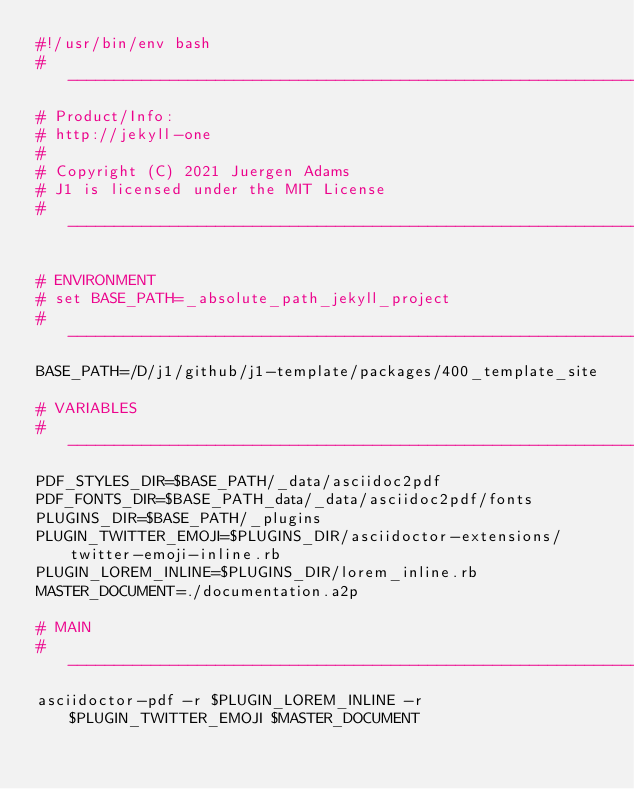<code> <loc_0><loc_0><loc_500><loc_500><_Bash_>#!/usr/bin/env bash
#  -----------------------------------------------------------------------------
# Product/Info:
# http://jekyll-one
#
# Copyright (C) 2021 Juergen Adams
# J1 is licensed under the MIT License
#  -----------------------------------------------------------------------------

# ENVIRONMENT
# set BASE_PATH=_absolute_path_jekyll_project
# ------------------------------------------------------------------------------
BASE_PATH=/D/j1/github/j1-template/packages/400_template_site

# VARIABLES
# ------------------------------------------------------------------------------
PDF_STYLES_DIR=$BASE_PATH/_data/asciidoc2pdf
PDF_FONTS_DIR=$BASE_PATH_data/_data/asciidoc2pdf/fonts
PLUGINS_DIR=$BASE_PATH/_plugins
PLUGIN_TWITTER_EMOJI=$PLUGINS_DIR/asciidoctor-extensions/twitter-emoji-inline.rb
PLUGIN_LOREM_INLINE=$PLUGINS_DIR/lorem_inline.rb
MASTER_DOCUMENT=./documentation.a2p

# MAIN
# ------------------------------------------------------------------------------
asciidoctor-pdf -r $PLUGIN_LOREM_INLINE -r $PLUGIN_TWITTER_EMOJI $MASTER_DOCUMENT
</code> 